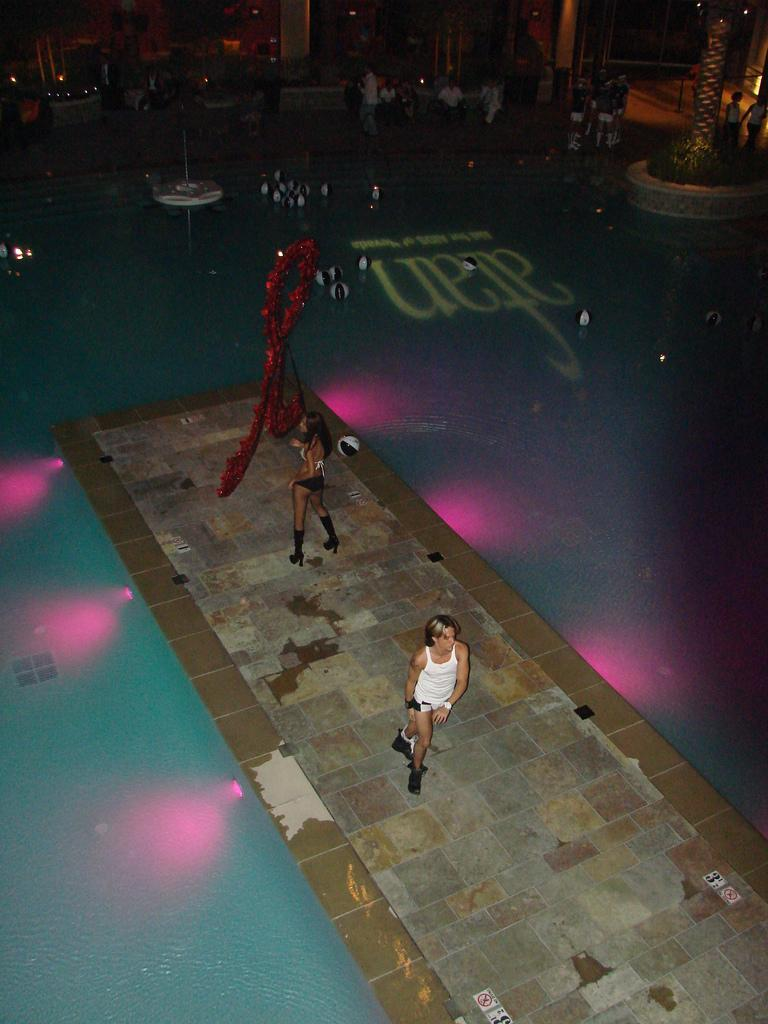What is happening with the two people in the image? The two people are in motion in the image. What color is the object that stands out in the image? There is a red object in the image. What can be seen in the water in the image? There are balls above the water in the image. What is visible in the background of the image? In the background of the image, there are people, a tree, plants, and lights. What type of carriage is being pulled by the horse in the image? There is no horse or carriage present in the image. What is the artist's medium for the canvas in the image? There is no canvas or artist present in the image. 